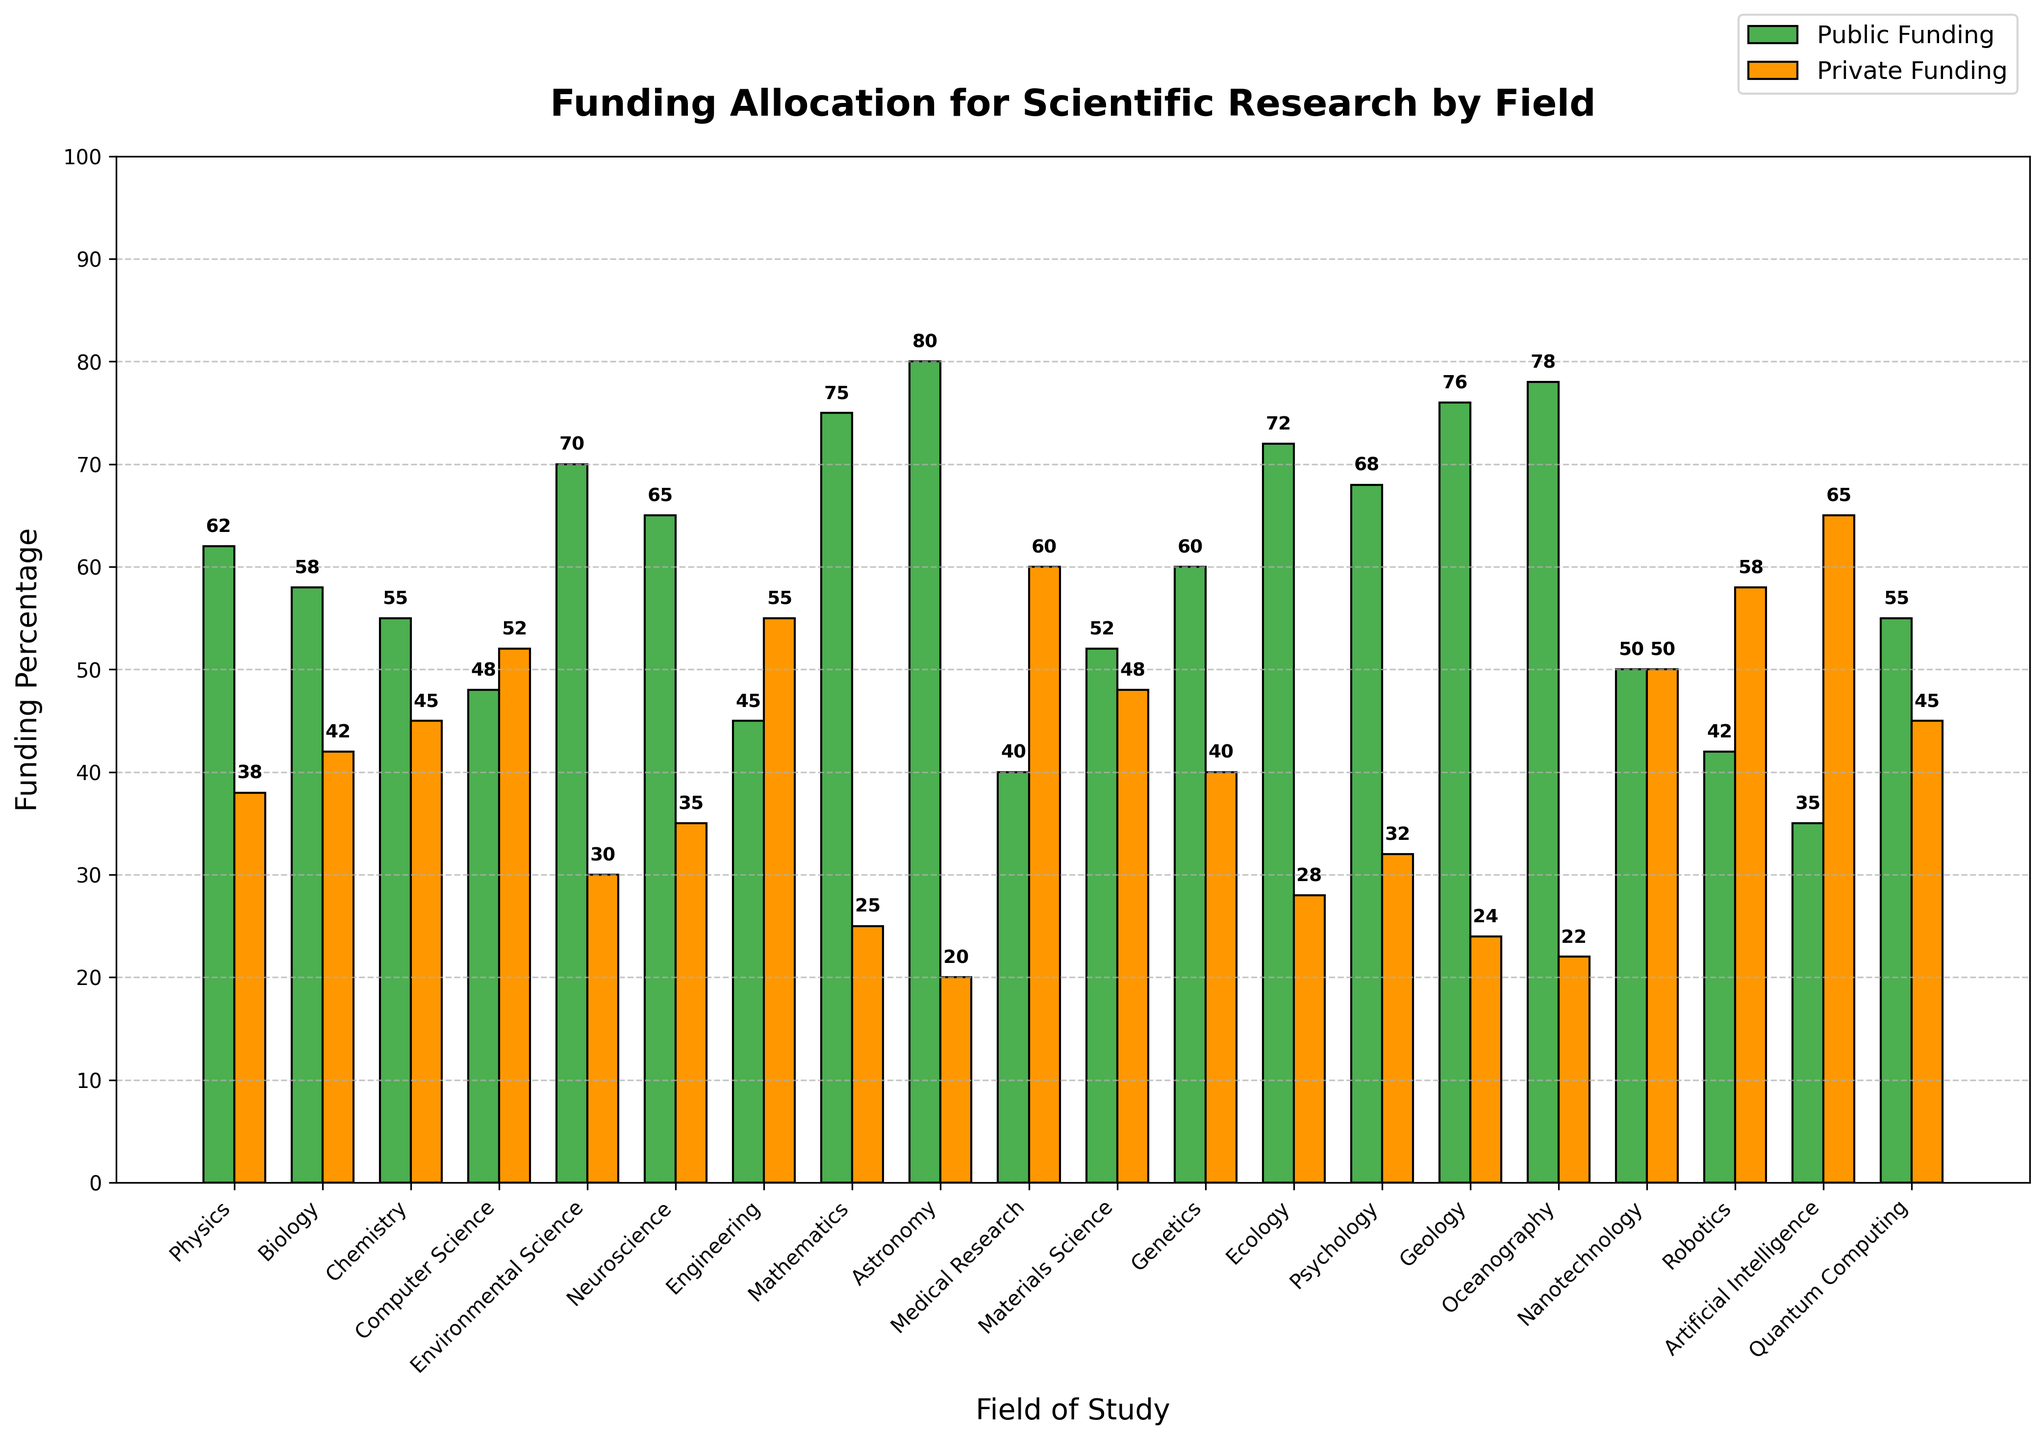Which field receives the highest percentage of public funding? Identify the tallest green bar, which represents the highest public funding.
Answer: Astronomy Which field receives the highest percentage of private funding? Identify the tallest orange bar, which represents the highest private funding.
Answer: Medical Research Which has a higher percentage of private funding, Robotics or Computer Science? Compare the heights of the orange bars for Robotics and Computer Science.
Answer: Computer Science What is the average percentage of public funding for the fields of Physics, Biology, and Chemistry? Sum the percentage values for Physics (62), Biology (58), and Chemistry (55) and divide by 3: (62 + 58 + 55)/3 = 175/3
Answer: 58.33 Does Quantum Computing receive more public funding than Nanotechnology? Compare the heights of the green bars for Quantum Computing (55%) and Nanotechnology (50%).
Answer: Yes Which fields receive an equal percentage of public and private funding? Identify fields where the heights of the green and orange bars are equal.
Answer: Nanotechnology Among Neuroscience, Genetics, and Psychology, which field has the highest total combined funding percentage from both sources? Add the public and private funding percentages for each field, then compare: Neuroscience (65 + 35 = 100), Genetics (60 + 40 = 100), Psychology (68 + 32 = 100)
Answer: Tie (All) What is the difference in public funding between Mathematics and Medical Research? Subtract the public funding percentage of Medical Research from that of Mathematics: Mathematics (75), Medical Research (40), 75 - 40 = 35
Answer: 35 Is public funding generally more prevalent than private funding across all fields? Visually compare the green bars (public funding) to the orange bars (private funding) across all fields.
Answer: Yes Which field has the lowest combined public and private funding percentage, and what is that value? Identify the field and calculate the sum of the public and private funding percentages for each. Compare to find the lowest sum: AI (35 + 65 = 100), Robotics (42 + 58 = 100), etc.
Answer: Tie (100) 